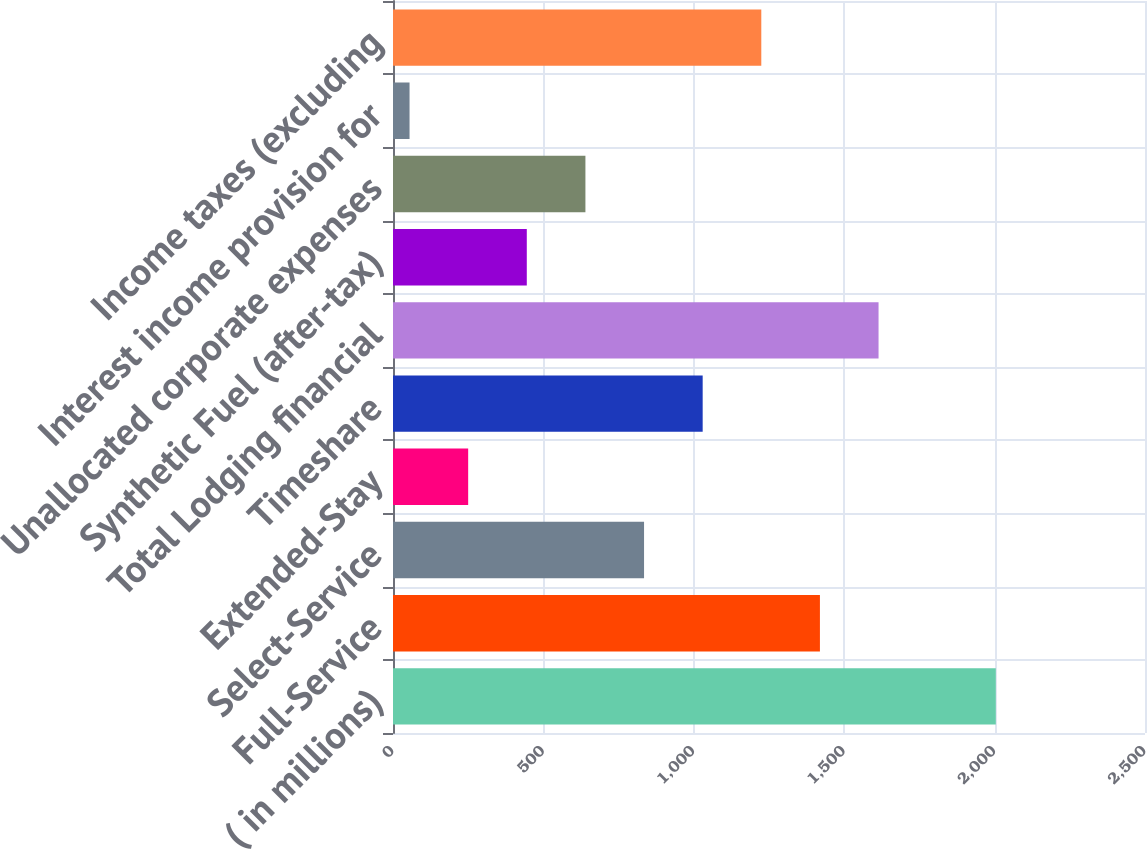Convert chart. <chart><loc_0><loc_0><loc_500><loc_500><bar_chart><fcel>( in millions)<fcel>Full-Service<fcel>Select-Service<fcel>Extended-Stay<fcel>Timeshare<fcel>Total Lodging financial<fcel>Synthetic Fuel (after-tax)<fcel>Unallocated corporate expenses<fcel>Interest income provision for<fcel>Income taxes (excluding<nl><fcel>2004<fcel>1419.3<fcel>834.6<fcel>249.9<fcel>1029.5<fcel>1614.2<fcel>444.8<fcel>639.7<fcel>55<fcel>1224.4<nl></chart> 